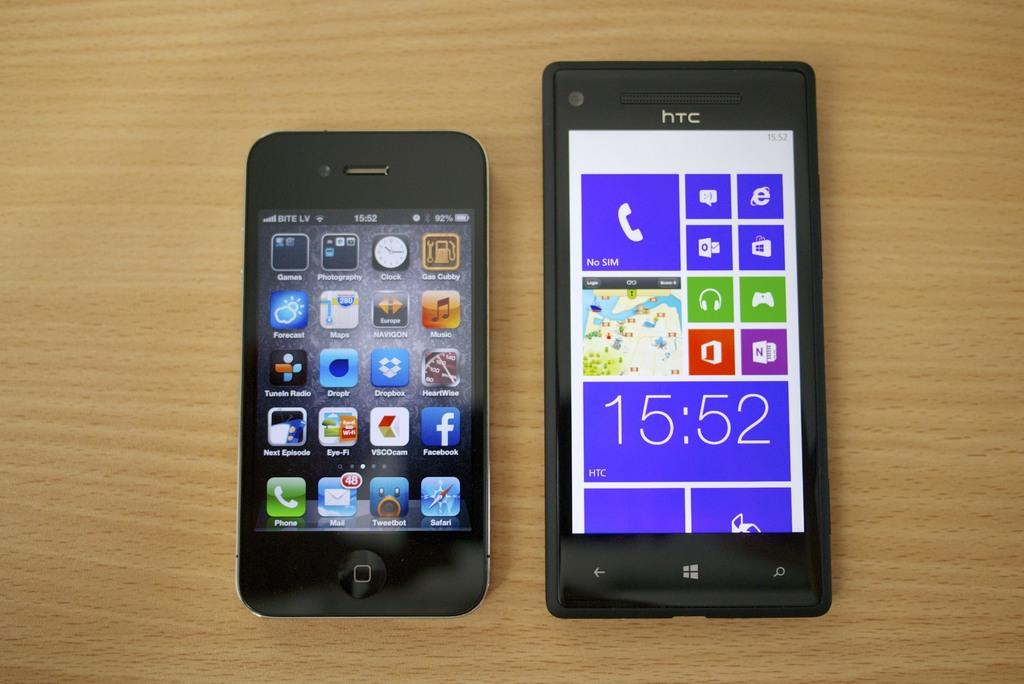What time is displayed on the phone on the right?
Your answer should be very brief. 15:52. Is there a facebook app on the phone?
Make the answer very short. Yes. 